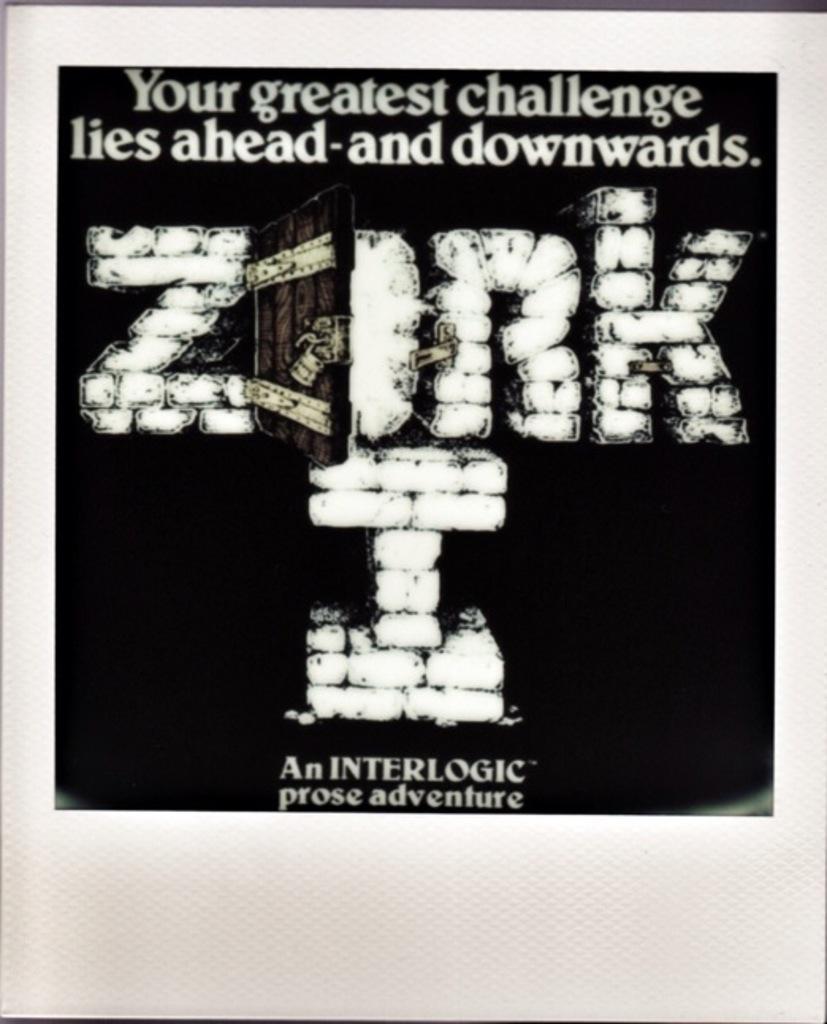Describe this image in one or two sentences. In this picture we can see a poster,on this poster we can see some text. 